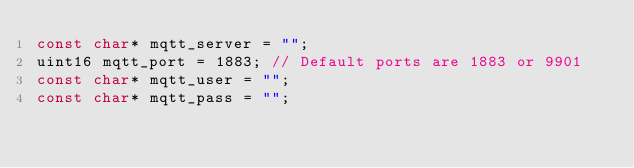<code> <loc_0><loc_0><loc_500><loc_500><_C_>const char* mqtt_server = "";
uint16 mqtt_port = 1883; // Default ports are 1883 or 9901
const char* mqtt_user = "";
const char* mqtt_pass = "";

</code> 